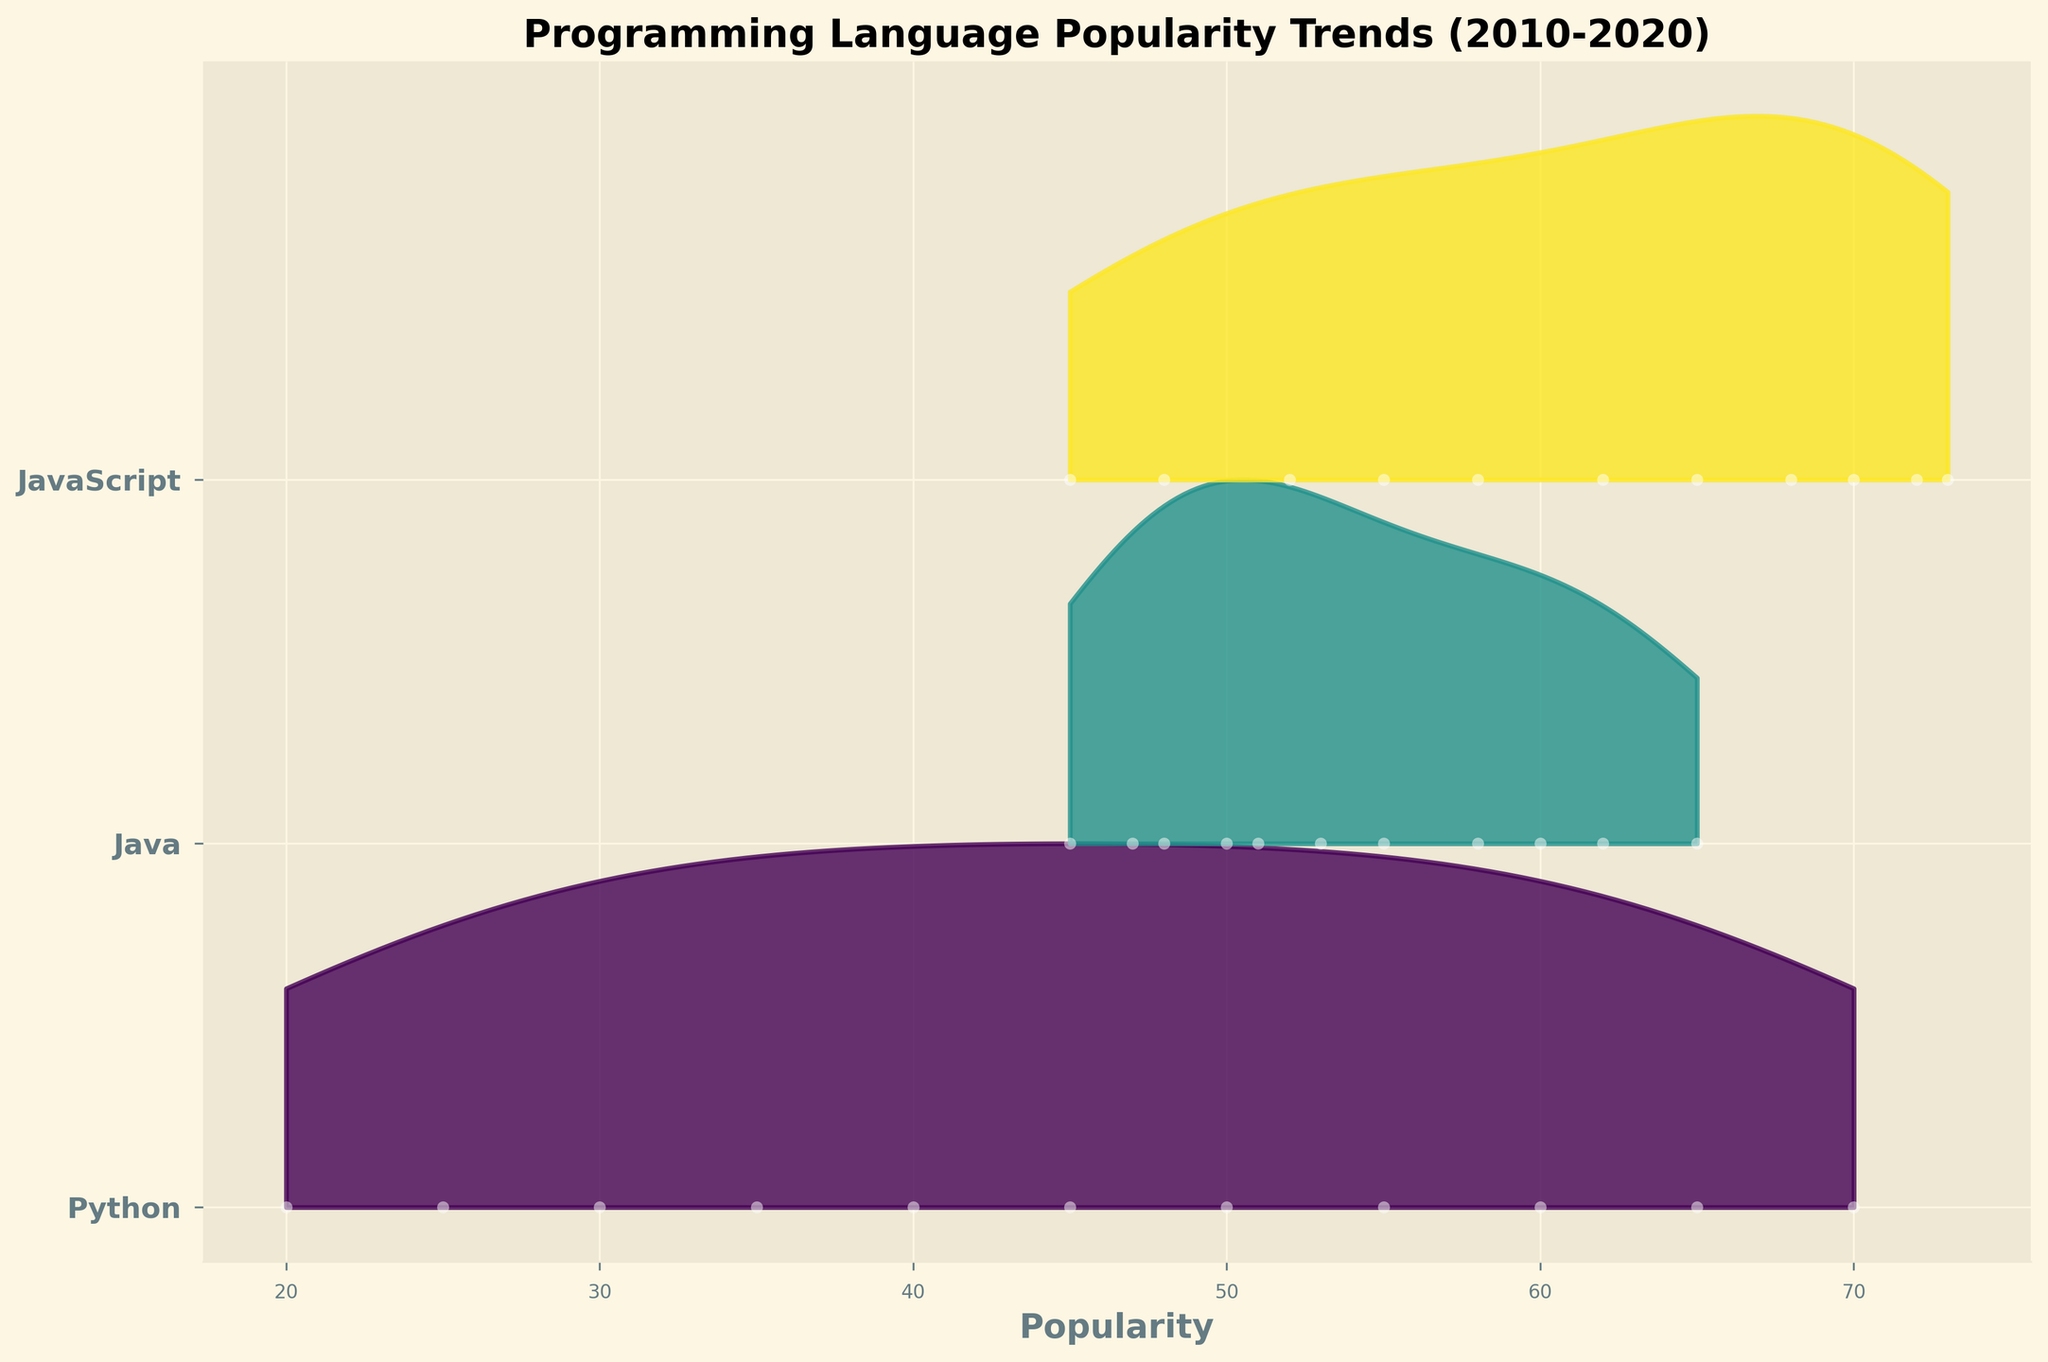What is the title of the figure? The title of the figure is located at the top of the plot and describes the overall content. In this case, the title reads "Programming Language Popularity Trends (2010-2020)."
Answer: Programming Language Popularity Trends (2010-2020) What are the x and y axes representing? The x-axis represents the popularity of programming languages, while the y-axis represents different programming languages.
Answer: x-axis: popularity, y-axis: programming languages Which programming language shows a continuous increase in popularity from 2010 to 2020? By observing the ridgeline for Python, we can see a continuous upward trend over the years, implying a continuous increase in popularity.
Answer: Python Which programming language had the highest popularity in 2020? By looking at the end of the timeline for 2020, the tallest peak belongs to JavaScript, indicating the highest popularity.
Answer: JavaScript Between Python and Java, which language was more popular on average over the 2010-2020 period? To determine this, observe the trends for Python and Java across the years. Python shows a consistent rise, surpassing Java post-2016. Java's popularity decreases, making Python more popular on average.
Answer: Python In which year did JavaScript first become more popular than Java? Comparing the heights of the Java and JavaScript peaks for each year, JavaScript surpasses Java in popularity beginning in 2011 and consistently thereafter.
Answer: 2011 In which year did Python first surpass Java in popularity? By comparing the heights of Python and Java ridgelines, Python surpasses Java in popularity starting in 2017.
Answer: 2017 Which language shows the most fluctuation in popularity over the years? By visually assessing the ridgelines, JavaScript shows the most fluctuation, with the popularity both significantly increasing and decreasing over different years.
Answer: JavaScript Which year had the greatest difference in popularity between Python and Java? To identify this, we compare the heights of the ridgelines for Python and Java each year. The year 2020 shows the greatest difference, with Python significantly more popular than Java.
Answer: 2020 What is the general trend for Java's popularity from 2010 to 2020? Java's popularity starts high in 2010 but declines steadily over the years, indicating a general downward trend.
Answer: Downward Trend 